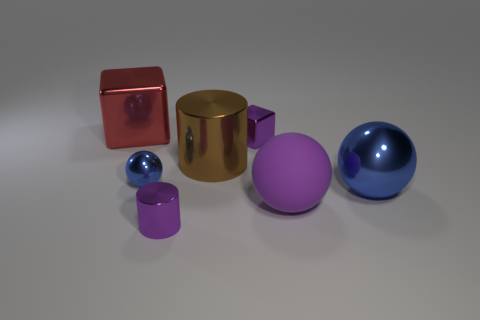Add 2 brown shiny cylinders. How many objects exist? 9 Subtract all blocks. How many objects are left? 5 Subtract all small yellow blocks. Subtract all small purple blocks. How many objects are left? 6 Add 2 large blue metal things. How many large blue metal things are left? 3 Add 7 large brown metal objects. How many large brown metal objects exist? 8 Subtract 0 gray blocks. How many objects are left? 7 